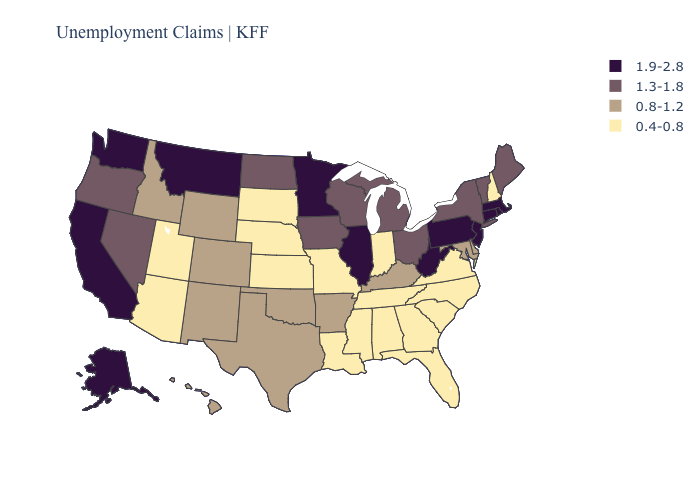Does Iowa have a higher value than Minnesota?
Be succinct. No. Name the states that have a value in the range 1.3-1.8?
Keep it brief. Iowa, Maine, Michigan, Nevada, New York, North Dakota, Ohio, Oregon, Vermont, Wisconsin. What is the value of Michigan?
Short answer required. 1.3-1.8. What is the value of Tennessee?
Give a very brief answer. 0.4-0.8. What is the value of Tennessee?
Keep it brief. 0.4-0.8. Which states have the highest value in the USA?
Concise answer only. Alaska, California, Connecticut, Illinois, Massachusetts, Minnesota, Montana, New Jersey, Pennsylvania, Rhode Island, Washington, West Virginia. Does Alabama have the lowest value in the USA?
Keep it brief. Yes. Name the states that have a value in the range 1.3-1.8?
Keep it brief. Iowa, Maine, Michigan, Nevada, New York, North Dakota, Ohio, Oregon, Vermont, Wisconsin. Name the states that have a value in the range 0.8-1.2?
Concise answer only. Arkansas, Colorado, Delaware, Hawaii, Idaho, Kentucky, Maryland, New Mexico, Oklahoma, Texas, Wyoming. How many symbols are there in the legend?
Give a very brief answer. 4. What is the value of Maine?
Keep it brief. 1.3-1.8. What is the highest value in states that border Rhode Island?
Keep it brief. 1.9-2.8. Name the states that have a value in the range 1.9-2.8?
Write a very short answer. Alaska, California, Connecticut, Illinois, Massachusetts, Minnesota, Montana, New Jersey, Pennsylvania, Rhode Island, Washington, West Virginia. What is the value of Nebraska?
Short answer required. 0.4-0.8. Does Louisiana have the same value as Georgia?
Be succinct. Yes. 